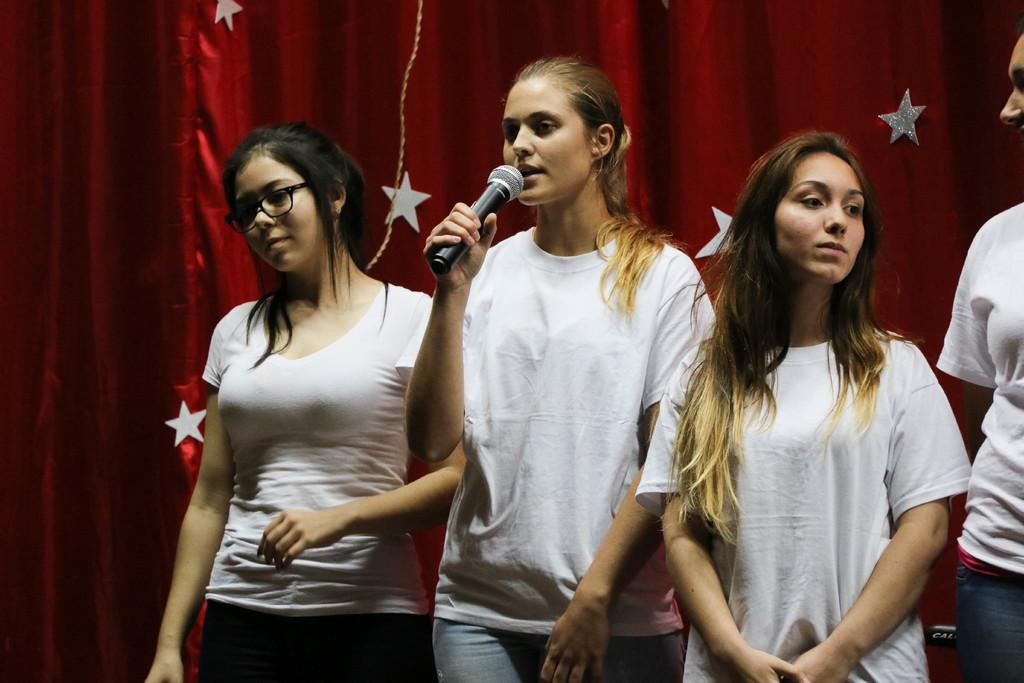How many people are standing in the image? There are four people standing in the image. What is one person doing with their hands? One person is holding a microphone. What is the person with the microphone doing? The person with the microphone is singing. What can be seen in the background of the image? There is a red curtain with stars present on it in the background. What type of dress is the manager wearing in the image? There is no manager present in the image, and therefore no dress to describe. 